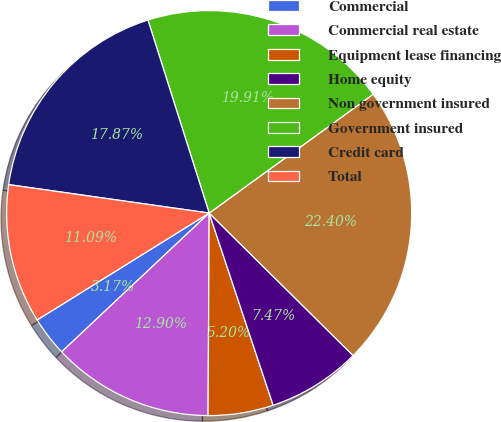Convert chart to OTSL. <chart><loc_0><loc_0><loc_500><loc_500><pie_chart><fcel>Commercial<fcel>Commercial real estate<fcel>Equipment lease financing<fcel>Home equity<fcel>Non government insured<fcel>Government insured<fcel>Credit card<fcel>Total<nl><fcel>3.17%<fcel>12.9%<fcel>5.2%<fcel>7.47%<fcel>22.4%<fcel>19.91%<fcel>17.87%<fcel>11.09%<nl></chart> 